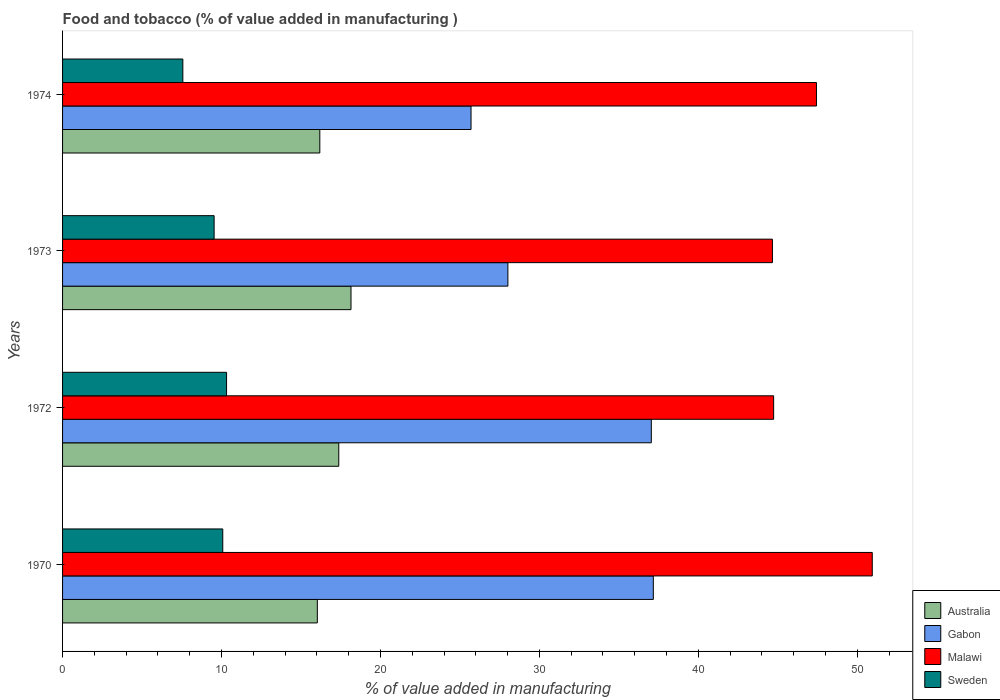How many groups of bars are there?
Offer a terse response. 4. How many bars are there on the 2nd tick from the top?
Your response must be concise. 4. How many bars are there on the 2nd tick from the bottom?
Your answer should be compact. 4. In how many cases, is the number of bars for a given year not equal to the number of legend labels?
Your answer should be very brief. 0. What is the value added in manufacturing food and tobacco in Gabon in 1970?
Give a very brief answer. 37.17. Across all years, what is the maximum value added in manufacturing food and tobacco in Australia?
Your answer should be compact. 18.15. Across all years, what is the minimum value added in manufacturing food and tobacco in Malawi?
Offer a very short reply. 44.66. In which year was the value added in manufacturing food and tobacco in Australia maximum?
Keep it short and to the point. 1973. In which year was the value added in manufacturing food and tobacco in Sweden minimum?
Keep it short and to the point. 1974. What is the total value added in manufacturing food and tobacco in Gabon in the graph?
Offer a terse response. 127.94. What is the difference between the value added in manufacturing food and tobacco in Gabon in 1972 and that in 1974?
Your answer should be very brief. 11.34. What is the difference between the value added in manufacturing food and tobacco in Malawi in 1970 and the value added in manufacturing food and tobacco in Sweden in 1974?
Offer a very short reply. 43.38. What is the average value added in manufacturing food and tobacco in Sweden per year?
Provide a short and direct response. 9.38. In the year 1974, what is the difference between the value added in manufacturing food and tobacco in Gabon and value added in manufacturing food and tobacco in Sweden?
Keep it short and to the point. 18.13. What is the ratio of the value added in manufacturing food and tobacco in Gabon in 1972 to that in 1974?
Provide a short and direct response. 1.44. What is the difference between the highest and the second highest value added in manufacturing food and tobacco in Gabon?
Ensure brevity in your answer.  0.13. What is the difference between the highest and the lowest value added in manufacturing food and tobacco in Sweden?
Your answer should be very brief. 2.75. In how many years, is the value added in manufacturing food and tobacco in Australia greater than the average value added in manufacturing food and tobacco in Australia taken over all years?
Your response must be concise. 2. What does the 3rd bar from the top in 1974 represents?
Provide a short and direct response. Gabon. What does the 3rd bar from the bottom in 1970 represents?
Give a very brief answer. Malawi. Is it the case that in every year, the sum of the value added in manufacturing food and tobacco in Sweden and value added in manufacturing food and tobacco in Gabon is greater than the value added in manufacturing food and tobacco in Malawi?
Keep it short and to the point. No. How many bars are there?
Your answer should be compact. 16. How many years are there in the graph?
Make the answer very short. 4. What is the difference between two consecutive major ticks on the X-axis?
Your response must be concise. 10. Does the graph contain any zero values?
Provide a succinct answer. No. Where does the legend appear in the graph?
Make the answer very short. Bottom right. What is the title of the graph?
Offer a terse response. Food and tobacco (% of value added in manufacturing ). Does "Peru" appear as one of the legend labels in the graph?
Give a very brief answer. No. What is the label or title of the X-axis?
Provide a short and direct response. % of value added in manufacturing. What is the % of value added in manufacturing in Australia in 1970?
Give a very brief answer. 16.03. What is the % of value added in manufacturing of Gabon in 1970?
Your answer should be compact. 37.17. What is the % of value added in manufacturing in Malawi in 1970?
Provide a short and direct response. 50.95. What is the % of value added in manufacturing in Sweden in 1970?
Your answer should be compact. 10.08. What is the % of value added in manufacturing of Australia in 1972?
Keep it short and to the point. 17.38. What is the % of value added in manufacturing in Gabon in 1972?
Provide a succinct answer. 37.04. What is the % of value added in manufacturing in Malawi in 1972?
Offer a terse response. 44.74. What is the % of value added in manufacturing of Sweden in 1972?
Offer a terse response. 10.32. What is the % of value added in manufacturing of Australia in 1973?
Keep it short and to the point. 18.15. What is the % of value added in manufacturing of Gabon in 1973?
Make the answer very short. 28.02. What is the % of value added in manufacturing in Malawi in 1973?
Make the answer very short. 44.66. What is the % of value added in manufacturing in Sweden in 1973?
Give a very brief answer. 9.54. What is the % of value added in manufacturing in Australia in 1974?
Ensure brevity in your answer.  16.19. What is the % of value added in manufacturing of Gabon in 1974?
Give a very brief answer. 25.7. What is the % of value added in manufacturing of Malawi in 1974?
Make the answer very short. 47.44. What is the % of value added in manufacturing in Sweden in 1974?
Give a very brief answer. 7.57. Across all years, what is the maximum % of value added in manufacturing of Australia?
Your response must be concise. 18.15. Across all years, what is the maximum % of value added in manufacturing of Gabon?
Offer a very short reply. 37.17. Across all years, what is the maximum % of value added in manufacturing of Malawi?
Provide a short and direct response. 50.95. Across all years, what is the maximum % of value added in manufacturing of Sweden?
Make the answer very short. 10.32. Across all years, what is the minimum % of value added in manufacturing in Australia?
Give a very brief answer. 16.03. Across all years, what is the minimum % of value added in manufacturing in Gabon?
Offer a terse response. 25.7. Across all years, what is the minimum % of value added in manufacturing in Malawi?
Ensure brevity in your answer.  44.66. Across all years, what is the minimum % of value added in manufacturing of Sweden?
Your response must be concise. 7.57. What is the total % of value added in manufacturing in Australia in the graph?
Offer a terse response. 67.74. What is the total % of value added in manufacturing in Gabon in the graph?
Make the answer very short. 127.94. What is the total % of value added in manufacturing of Malawi in the graph?
Give a very brief answer. 187.79. What is the total % of value added in manufacturing of Sweden in the graph?
Ensure brevity in your answer.  37.5. What is the difference between the % of value added in manufacturing of Australia in 1970 and that in 1972?
Your response must be concise. -1.35. What is the difference between the % of value added in manufacturing of Gabon in 1970 and that in 1972?
Your answer should be very brief. 0.13. What is the difference between the % of value added in manufacturing in Malawi in 1970 and that in 1972?
Offer a very short reply. 6.21. What is the difference between the % of value added in manufacturing of Sweden in 1970 and that in 1972?
Your response must be concise. -0.24. What is the difference between the % of value added in manufacturing of Australia in 1970 and that in 1973?
Offer a terse response. -2.12. What is the difference between the % of value added in manufacturing of Gabon in 1970 and that in 1973?
Your answer should be very brief. 9.15. What is the difference between the % of value added in manufacturing of Malawi in 1970 and that in 1973?
Make the answer very short. 6.28. What is the difference between the % of value added in manufacturing in Sweden in 1970 and that in 1973?
Your answer should be very brief. 0.54. What is the difference between the % of value added in manufacturing in Australia in 1970 and that in 1974?
Give a very brief answer. -0.16. What is the difference between the % of value added in manufacturing of Gabon in 1970 and that in 1974?
Provide a short and direct response. 11.47. What is the difference between the % of value added in manufacturing of Malawi in 1970 and that in 1974?
Provide a short and direct response. 3.51. What is the difference between the % of value added in manufacturing of Sweden in 1970 and that in 1974?
Your answer should be compact. 2.51. What is the difference between the % of value added in manufacturing of Australia in 1972 and that in 1973?
Offer a terse response. -0.77. What is the difference between the % of value added in manufacturing of Gabon in 1972 and that in 1973?
Make the answer very short. 9.02. What is the difference between the % of value added in manufacturing of Malawi in 1972 and that in 1973?
Provide a succinct answer. 0.08. What is the difference between the % of value added in manufacturing in Sweden in 1972 and that in 1973?
Keep it short and to the point. 0.78. What is the difference between the % of value added in manufacturing of Australia in 1972 and that in 1974?
Keep it short and to the point. 1.19. What is the difference between the % of value added in manufacturing of Gabon in 1972 and that in 1974?
Provide a short and direct response. 11.34. What is the difference between the % of value added in manufacturing in Malawi in 1972 and that in 1974?
Keep it short and to the point. -2.7. What is the difference between the % of value added in manufacturing in Sweden in 1972 and that in 1974?
Your answer should be very brief. 2.75. What is the difference between the % of value added in manufacturing in Australia in 1973 and that in 1974?
Offer a very short reply. 1.96. What is the difference between the % of value added in manufacturing of Gabon in 1973 and that in 1974?
Ensure brevity in your answer.  2.32. What is the difference between the % of value added in manufacturing in Malawi in 1973 and that in 1974?
Keep it short and to the point. -2.77. What is the difference between the % of value added in manufacturing in Sweden in 1973 and that in 1974?
Your answer should be compact. 1.97. What is the difference between the % of value added in manufacturing of Australia in 1970 and the % of value added in manufacturing of Gabon in 1972?
Give a very brief answer. -21.01. What is the difference between the % of value added in manufacturing in Australia in 1970 and the % of value added in manufacturing in Malawi in 1972?
Provide a succinct answer. -28.71. What is the difference between the % of value added in manufacturing of Australia in 1970 and the % of value added in manufacturing of Sweden in 1972?
Offer a terse response. 5.71. What is the difference between the % of value added in manufacturing of Gabon in 1970 and the % of value added in manufacturing of Malawi in 1972?
Provide a succinct answer. -7.57. What is the difference between the % of value added in manufacturing in Gabon in 1970 and the % of value added in manufacturing in Sweden in 1972?
Provide a succinct answer. 26.85. What is the difference between the % of value added in manufacturing in Malawi in 1970 and the % of value added in manufacturing in Sweden in 1972?
Keep it short and to the point. 40.63. What is the difference between the % of value added in manufacturing of Australia in 1970 and the % of value added in manufacturing of Gabon in 1973?
Provide a succinct answer. -11.99. What is the difference between the % of value added in manufacturing in Australia in 1970 and the % of value added in manufacturing in Malawi in 1973?
Ensure brevity in your answer.  -28.63. What is the difference between the % of value added in manufacturing in Australia in 1970 and the % of value added in manufacturing in Sweden in 1973?
Make the answer very short. 6.49. What is the difference between the % of value added in manufacturing in Gabon in 1970 and the % of value added in manufacturing in Malawi in 1973?
Keep it short and to the point. -7.49. What is the difference between the % of value added in manufacturing in Gabon in 1970 and the % of value added in manufacturing in Sweden in 1973?
Provide a succinct answer. 27.63. What is the difference between the % of value added in manufacturing in Malawi in 1970 and the % of value added in manufacturing in Sweden in 1973?
Offer a terse response. 41.41. What is the difference between the % of value added in manufacturing in Australia in 1970 and the % of value added in manufacturing in Gabon in 1974?
Ensure brevity in your answer.  -9.67. What is the difference between the % of value added in manufacturing in Australia in 1970 and the % of value added in manufacturing in Malawi in 1974?
Keep it short and to the point. -31.41. What is the difference between the % of value added in manufacturing of Australia in 1970 and the % of value added in manufacturing of Sweden in 1974?
Offer a very short reply. 8.46. What is the difference between the % of value added in manufacturing in Gabon in 1970 and the % of value added in manufacturing in Malawi in 1974?
Offer a terse response. -10.26. What is the difference between the % of value added in manufacturing of Gabon in 1970 and the % of value added in manufacturing of Sweden in 1974?
Offer a very short reply. 29.6. What is the difference between the % of value added in manufacturing in Malawi in 1970 and the % of value added in manufacturing in Sweden in 1974?
Make the answer very short. 43.38. What is the difference between the % of value added in manufacturing of Australia in 1972 and the % of value added in manufacturing of Gabon in 1973?
Your answer should be compact. -10.64. What is the difference between the % of value added in manufacturing in Australia in 1972 and the % of value added in manufacturing in Malawi in 1973?
Provide a succinct answer. -27.29. What is the difference between the % of value added in manufacturing in Australia in 1972 and the % of value added in manufacturing in Sweden in 1973?
Offer a very short reply. 7.84. What is the difference between the % of value added in manufacturing of Gabon in 1972 and the % of value added in manufacturing of Malawi in 1973?
Offer a very short reply. -7.62. What is the difference between the % of value added in manufacturing of Gabon in 1972 and the % of value added in manufacturing of Sweden in 1973?
Your answer should be compact. 27.51. What is the difference between the % of value added in manufacturing of Malawi in 1972 and the % of value added in manufacturing of Sweden in 1973?
Give a very brief answer. 35.2. What is the difference between the % of value added in manufacturing in Australia in 1972 and the % of value added in manufacturing in Gabon in 1974?
Provide a succinct answer. -8.32. What is the difference between the % of value added in manufacturing of Australia in 1972 and the % of value added in manufacturing of Malawi in 1974?
Offer a very short reply. -30.06. What is the difference between the % of value added in manufacturing of Australia in 1972 and the % of value added in manufacturing of Sweden in 1974?
Keep it short and to the point. 9.81. What is the difference between the % of value added in manufacturing of Gabon in 1972 and the % of value added in manufacturing of Malawi in 1974?
Keep it short and to the point. -10.39. What is the difference between the % of value added in manufacturing in Gabon in 1972 and the % of value added in manufacturing in Sweden in 1974?
Provide a short and direct response. 29.48. What is the difference between the % of value added in manufacturing of Malawi in 1972 and the % of value added in manufacturing of Sweden in 1974?
Offer a very short reply. 37.17. What is the difference between the % of value added in manufacturing of Australia in 1973 and the % of value added in manufacturing of Gabon in 1974?
Offer a terse response. -7.55. What is the difference between the % of value added in manufacturing in Australia in 1973 and the % of value added in manufacturing in Malawi in 1974?
Provide a succinct answer. -29.29. What is the difference between the % of value added in manufacturing of Australia in 1973 and the % of value added in manufacturing of Sweden in 1974?
Offer a terse response. 10.58. What is the difference between the % of value added in manufacturing of Gabon in 1973 and the % of value added in manufacturing of Malawi in 1974?
Provide a short and direct response. -19.42. What is the difference between the % of value added in manufacturing of Gabon in 1973 and the % of value added in manufacturing of Sweden in 1974?
Provide a short and direct response. 20.45. What is the difference between the % of value added in manufacturing in Malawi in 1973 and the % of value added in manufacturing in Sweden in 1974?
Ensure brevity in your answer.  37.1. What is the average % of value added in manufacturing of Australia per year?
Your answer should be compact. 16.94. What is the average % of value added in manufacturing of Gabon per year?
Offer a very short reply. 31.98. What is the average % of value added in manufacturing in Malawi per year?
Your response must be concise. 46.95. What is the average % of value added in manufacturing in Sweden per year?
Make the answer very short. 9.38. In the year 1970, what is the difference between the % of value added in manufacturing of Australia and % of value added in manufacturing of Gabon?
Keep it short and to the point. -21.14. In the year 1970, what is the difference between the % of value added in manufacturing in Australia and % of value added in manufacturing in Malawi?
Ensure brevity in your answer.  -34.92. In the year 1970, what is the difference between the % of value added in manufacturing in Australia and % of value added in manufacturing in Sweden?
Your answer should be very brief. 5.95. In the year 1970, what is the difference between the % of value added in manufacturing of Gabon and % of value added in manufacturing of Malawi?
Your response must be concise. -13.78. In the year 1970, what is the difference between the % of value added in manufacturing of Gabon and % of value added in manufacturing of Sweden?
Your answer should be compact. 27.09. In the year 1970, what is the difference between the % of value added in manufacturing in Malawi and % of value added in manufacturing in Sweden?
Offer a terse response. 40.87. In the year 1972, what is the difference between the % of value added in manufacturing in Australia and % of value added in manufacturing in Gabon?
Your response must be concise. -19.67. In the year 1972, what is the difference between the % of value added in manufacturing in Australia and % of value added in manufacturing in Malawi?
Provide a succinct answer. -27.36. In the year 1972, what is the difference between the % of value added in manufacturing in Australia and % of value added in manufacturing in Sweden?
Keep it short and to the point. 7.06. In the year 1972, what is the difference between the % of value added in manufacturing of Gabon and % of value added in manufacturing of Malawi?
Provide a succinct answer. -7.7. In the year 1972, what is the difference between the % of value added in manufacturing of Gabon and % of value added in manufacturing of Sweden?
Your answer should be very brief. 26.73. In the year 1972, what is the difference between the % of value added in manufacturing in Malawi and % of value added in manufacturing in Sweden?
Ensure brevity in your answer.  34.42. In the year 1973, what is the difference between the % of value added in manufacturing of Australia and % of value added in manufacturing of Gabon?
Offer a very short reply. -9.87. In the year 1973, what is the difference between the % of value added in manufacturing of Australia and % of value added in manufacturing of Malawi?
Offer a terse response. -26.52. In the year 1973, what is the difference between the % of value added in manufacturing of Australia and % of value added in manufacturing of Sweden?
Your response must be concise. 8.61. In the year 1973, what is the difference between the % of value added in manufacturing in Gabon and % of value added in manufacturing in Malawi?
Your answer should be very brief. -16.64. In the year 1973, what is the difference between the % of value added in manufacturing of Gabon and % of value added in manufacturing of Sweden?
Offer a terse response. 18.48. In the year 1973, what is the difference between the % of value added in manufacturing in Malawi and % of value added in manufacturing in Sweden?
Your answer should be very brief. 35.13. In the year 1974, what is the difference between the % of value added in manufacturing in Australia and % of value added in manufacturing in Gabon?
Your response must be concise. -9.52. In the year 1974, what is the difference between the % of value added in manufacturing in Australia and % of value added in manufacturing in Malawi?
Provide a short and direct response. -31.25. In the year 1974, what is the difference between the % of value added in manufacturing in Australia and % of value added in manufacturing in Sweden?
Keep it short and to the point. 8.62. In the year 1974, what is the difference between the % of value added in manufacturing in Gabon and % of value added in manufacturing in Malawi?
Offer a very short reply. -21.73. In the year 1974, what is the difference between the % of value added in manufacturing in Gabon and % of value added in manufacturing in Sweden?
Give a very brief answer. 18.13. In the year 1974, what is the difference between the % of value added in manufacturing in Malawi and % of value added in manufacturing in Sweden?
Your answer should be very brief. 39.87. What is the ratio of the % of value added in manufacturing in Australia in 1970 to that in 1972?
Provide a succinct answer. 0.92. What is the ratio of the % of value added in manufacturing of Gabon in 1970 to that in 1972?
Your answer should be compact. 1. What is the ratio of the % of value added in manufacturing of Malawi in 1970 to that in 1972?
Offer a terse response. 1.14. What is the ratio of the % of value added in manufacturing of Sweden in 1970 to that in 1972?
Your response must be concise. 0.98. What is the ratio of the % of value added in manufacturing of Australia in 1970 to that in 1973?
Your answer should be very brief. 0.88. What is the ratio of the % of value added in manufacturing of Gabon in 1970 to that in 1973?
Offer a very short reply. 1.33. What is the ratio of the % of value added in manufacturing of Malawi in 1970 to that in 1973?
Give a very brief answer. 1.14. What is the ratio of the % of value added in manufacturing in Sweden in 1970 to that in 1973?
Offer a terse response. 1.06. What is the ratio of the % of value added in manufacturing in Australia in 1970 to that in 1974?
Offer a very short reply. 0.99. What is the ratio of the % of value added in manufacturing of Gabon in 1970 to that in 1974?
Your answer should be very brief. 1.45. What is the ratio of the % of value added in manufacturing in Malawi in 1970 to that in 1974?
Your answer should be very brief. 1.07. What is the ratio of the % of value added in manufacturing of Sweden in 1970 to that in 1974?
Make the answer very short. 1.33. What is the ratio of the % of value added in manufacturing of Australia in 1972 to that in 1973?
Offer a very short reply. 0.96. What is the ratio of the % of value added in manufacturing of Gabon in 1972 to that in 1973?
Offer a terse response. 1.32. What is the ratio of the % of value added in manufacturing of Malawi in 1972 to that in 1973?
Your response must be concise. 1. What is the ratio of the % of value added in manufacturing in Sweden in 1972 to that in 1973?
Offer a terse response. 1.08. What is the ratio of the % of value added in manufacturing in Australia in 1972 to that in 1974?
Offer a very short reply. 1.07. What is the ratio of the % of value added in manufacturing of Gabon in 1972 to that in 1974?
Your answer should be very brief. 1.44. What is the ratio of the % of value added in manufacturing of Malawi in 1972 to that in 1974?
Your answer should be very brief. 0.94. What is the ratio of the % of value added in manufacturing of Sweden in 1972 to that in 1974?
Keep it short and to the point. 1.36. What is the ratio of the % of value added in manufacturing in Australia in 1973 to that in 1974?
Your response must be concise. 1.12. What is the ratio of the % of value added in manufacturing of Gabon in 1973 to that in 1974?
Your answer should be compact. 1.09. What is the ratio of the % of value added in manufacturing in Malawi in 1973 to that in 1974?
Give a very brief answer. 0.94. What is the ratio of the % of value added in manufacturing of Sweden in 1973 to that in 1974?
Keep it short and to the point. 1.26. What is the difference between the highest and the second highest % of value added in manufacturing of Australia?
Provide a succinct answer. 0.77. What is the difference between the highest and the second highest % of value added in manufacturing in Gabon?
Give a very brief answer. 0.13. What is the difference between the highest and the second highest % of value added in manufacturing of Malawi?
Provide a short and direct response. 3.51. What is the difference between the highest and the second highest % of value added in manufacturing of Sweden?
Your answer should be compact. 0.24. What is the difference between the highest and the lowest % of value added in manufacturing in Australia?
Make the answer very short. 2.12. What is the difference between the highest and the lowest % of value added in manufacturing in Gabon?
Offer a terse response. 11.47. What is the difference between the highest and the lowest % of value added in manufacturing of Malawi?
Provide a short and direct response. 6.28. What is the difference between the highest and the lowest % of value added in manufacturing in Sweden?
Provide a short and direct response. 2.75. 